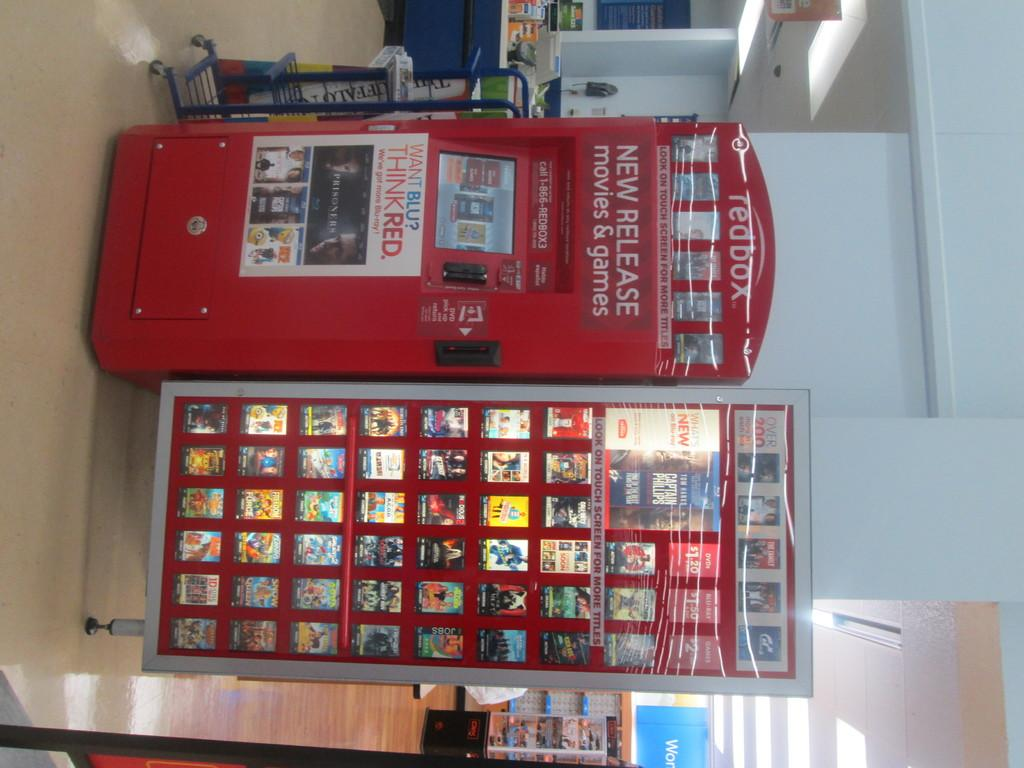<image>
Summarize the visual content of the image. a red tedbox vending machine despenser for renting dvd movies 